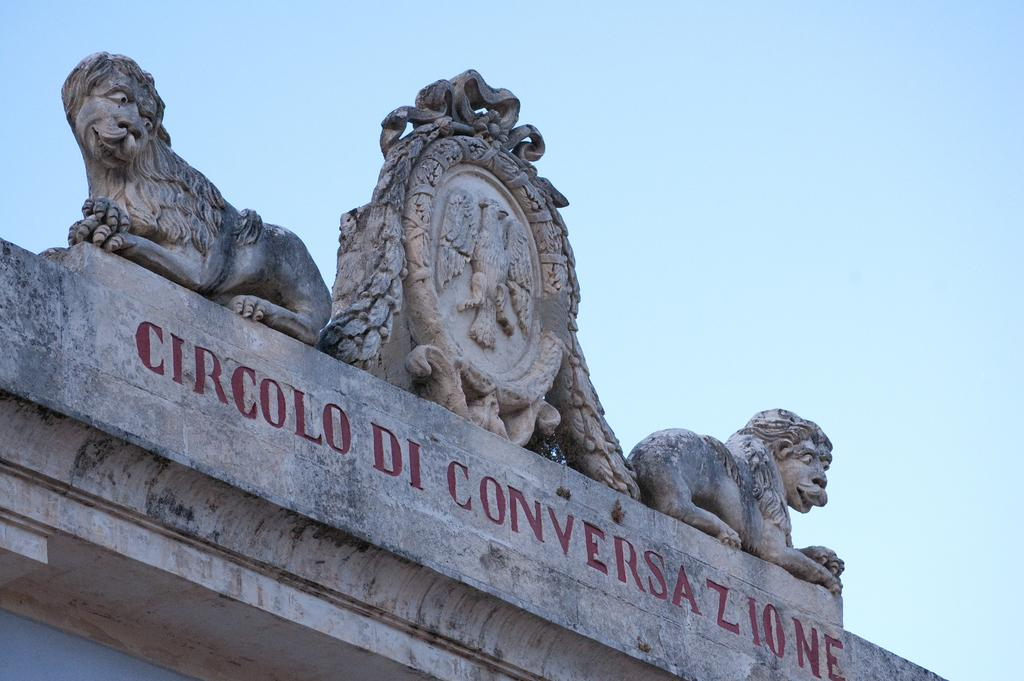What type of animal is depicted in the statues in the image? There are two lion statues in the image. Where are the lion statues located? The lion statues are on top of a building. What can be seen on the wall of the building? There is text engraved on the wall of the building. How many kittens are playing on the roof of the building in the image? There are no kittens present in the image; it features two lion statues on top of a building. What type of structure is the building in the image? The provided facts do not give enough information to determine the type of structure the building is. 